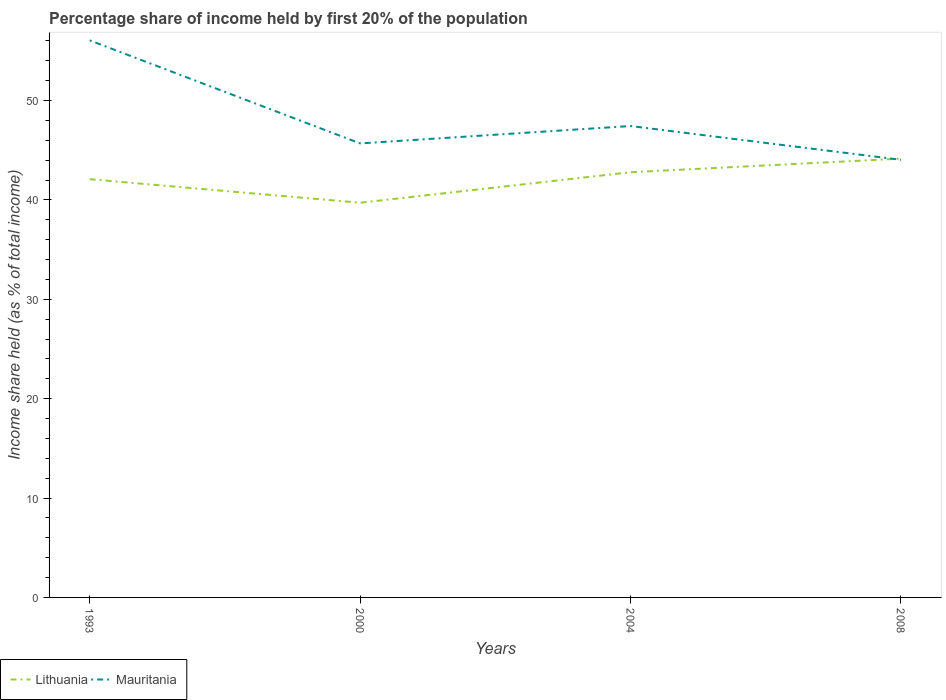How many different coloured lines are there?
Make the answer very short. 2. Is the number of lines equal to the number of legend labels?
Keep it short and to the point. Yes. Across all years, what is the maximum share of income held by first 20% of the population in Mauritania?
Offer a terse response. 44.04. In which year was the share of income held by first 20% of the population in Mauritania maximum?
Ensure brevity in your answer.  2008. What is the total share of income held by first 20% of the population in Mauritania in the graph?
Your answer should be very brief. 3.4. What is the difference between the highest and the second highest share of income held by first 20% of the population in Lithuania?
Give a very brief answer. 4.44. Are the values on the major ticks of Y-axis written in scientific E-notation?
Provide a succinct answer. No. Where does the legend appear in the graph?
Provide a succinct answer. Bottom left. How many legend labels are there?
Your answer should be very brief. 2. How are the legend labels stacked?
Keep it short and to the point. Horizontal. What is the title of the graph?
Provide a short and direct response. Percentage share of income held by first 20% of the population. Does "Korea (Republic)" appear as one of the legend labels in the graph?
Provide a short and direct response. No. What is the label or title of the X-axis?
Make the answer very short. Years. What is the label or title of the Y-axis?
Offer a terse response. Income share held (as % of total income). What is the Income share held (as % of total income) of Lithuania in 1993?
Offer a very short reply. 42.09. What is the Income share held (as % of total income) in Mauritania in 1993?
Ensure brevity in your answer.  56.06. What is the Income share held (as % of total income) in Lithuania in 2000?
Your response must be concise. 39.72. What is the Income share held (as % of total income) of Mauritania in 2000?
Ensure brevity in your answer.  45.69. What is the Income share held (as % of total income) in Lithuania in 2004?
Provide a succinct answer. 42.79. What is the Income share held (as % of total income) of Mauritania in 2004?
Offer a terse response. 47.44. What is the Income share held (as % of total income) in Lithuania in 2008?
Your answer should be very brief. 44.16. What is the Income share held (as % of total income) in Mauritania in 2008?
Offer a very short reply. 44.04. Across all years, what is the maximum Income share held (as % of total income) of Lithuania?
Your answer should be compact. 44.16. Across all years, what is the maximum Income share held (as % of total income) of Mauritania?
Your answer should be compact. 56.06. Across all years, what is the minimum Income share held (as % of total income) in Lithuania?
Give a very brief answer. 39.72. Across all years, what is the minimum Income share held (as % of total income) of Mauritania?
Your response must be concise. 44.04. What is the total Income share held (as % of total income) in Lithuania in the graph?
Your answer should be compact. 168.76. What is the total Income share held (as % of total income) of Mauritania in the graph?
Make the answer very short. 193.23. What is the difference between the Income share held (as % of total income) in Lithuania in 1993 and that in 2000?
Give a very brief answer. 2.37. What is the difference between the Income share held (as % of total income) in Mauritania in 1993 and that in 2000?
Keep it short and to the point. 10.37. What is the difference between the Income share held (as % of total income) in Mauritania in 1993 and that in 2004?
Provide a succinct answer. 8.62. What is the difference between the Income share held (as % of total income) of Lithuania in 1993 and that in 2008?
Keep it short and to the point. -2.07. What is the difference between the Income share held (as % of total income) in Mauritania in 1993 and that in 2008?
Keep it short and to the point. 12.02. What is the difference between the Income share held (as % of total income) of Lithuania in 2000 and that in 2004?
Give a very brief answer. -3.07. What is the difference between the Income share held (as % of total income) in Mauritania in 2000 and that in 2004?
Your answer should be very brief. -1.75. What is the difference between the Income share held (as % of total income) in Lithuania in 2000 and that in 2008?
Your answer should be very brief. -4.44. What is the difference between the Income share held (as % of total income) of Mauritania in 2000 and that in 2008?
Your answer should be very brief. 1.65. What is the difference between the Income share held (as % of total income) of Lithuania in 2004 and that in 2008?
Your response must be concise. -1.37. What is the difference between the Income share held (as % of total income) in Lithuania in 1993 and the Income share held (as % of total income) in Mauritania in 2004?
Your answer should be compact. -5.35. What is the difference between the Income share held (as % of total income) of Lithuania in 1993 and the Income share held (as % of total income) of Mauritania in 2008?
Your answer should be compact. -1.95. What is the difference between the Income share held (as % of total income) in Lithuania in 2000 and the Income share held (as % of total income) in Mauritania in 2004?
Give a very brief answer. -7.72. What is the difference between the Income share held (as % of total income) of Lithuania in 2000 and the Income share held (as % of total income) of Mauritania in 2008?
Your answer should be compact. -4.32. What is the difference between the Income share held (as % of total income) in Lithuania in 2004 and the Income share held (as % of total income) in Mauritania in 2008?
Provide a succinct answer. -1.25. What is the average Income share held (as % of total income) in Lithuania per year?
Provide a short and direct response. 42.19. What is the average Income share held (as % of total income) of Mauritania per year?
Provide a short and direct response. 48.31. In the year 1993, what is the difference between the Income share held (as % of total income) in Lithuania and Income share held (as % of total income) in Mauritania?
Give a very brief answer. -13.97. In the year 2000, what is the difference between the Income share held (as % of total income) in Lithuania and Income share held (as % of total income) in Mauritania?
Give a very brief answer. -5.97. In the year 2004, what is the difference between the Income share held (as % of total income) of Lithuania and Income share held (as % of total income) of Mauritania?
Ensure brevity in your answer.  -4.65. In the year 2008, what is the difference between the Income share held (as % of total income) of Lithuania and Income share held (as % of total income) of Mauritania?
Your answer should be very brief. 0.12. What is the ratio of the Income share held (as % of total income) in Lithuania in 1993 to that in 2000?
Make the answer very short. 1.06. What is the ratio of the Income share held (as % of total income) in Mauritania in 1993 to that in 2000?
Keep it short and to the point. 1.23. What is the ratio of the Income share held (as % of total income) in Lithuania in 1993 to that in 2004?
Give a very brief answer. 0.98. What is the ratio of the Income share held (as % of total income) in Mauritania in 1993 to that in 2004?
Make the answer very short. 1.18. What is the ratio of the Income share held (as % of total income) in Lithuania in 1993 to that in 2008?
Make the answer very short. 0.95. What is the ratio of the Income share held (as % of total income) in Mauritania in 1993 to that in 2008?
Your response must be concise. 1.27. What is the ratio of the Income share held (as % of total income) in Lithuania in 2000 to that in 2004?
Your answer should be compact. 0.93. What is the ratio of the Income share held (as % of total income) in Mauritania in 2000 to that in 2004?
Your answer should be compact. 0.96. What is the ratio of the Income share held (as % of total income) in Lithuania in 2000 to that in 2008?
Offer a terse response. 0.9. What is the ratio of the Income share held (as % of total income) of Mauritania in 2000 to that in 2008?
Offer a terse response. 1.04. What is the ratio of the Income share held (as % of total income) in Mauritania in 2004 to that in 2008?
Provide a succinct answer. 1.08. What is the difference between the highest and the second highest Income share held (as % of total income) of Lithuania?
Make the answer very short. 1.37. What is the difference between the highest and the second highest Income share held (as % of total income) of Mauritania?
Keep it short and to the point. 8.62. What is the difference between the highest and the lowest Income share held (as % of total income) of Lithuania?
Offer a terse response. 4.44. What is the difference between the highest and the lowest Income share held (as % of total income) of Mauritania?
Make the answer very short. 12.02. 